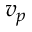<formula> <loc_0><loc_0><loc_500><loc_500>v _ { p }</formula> 